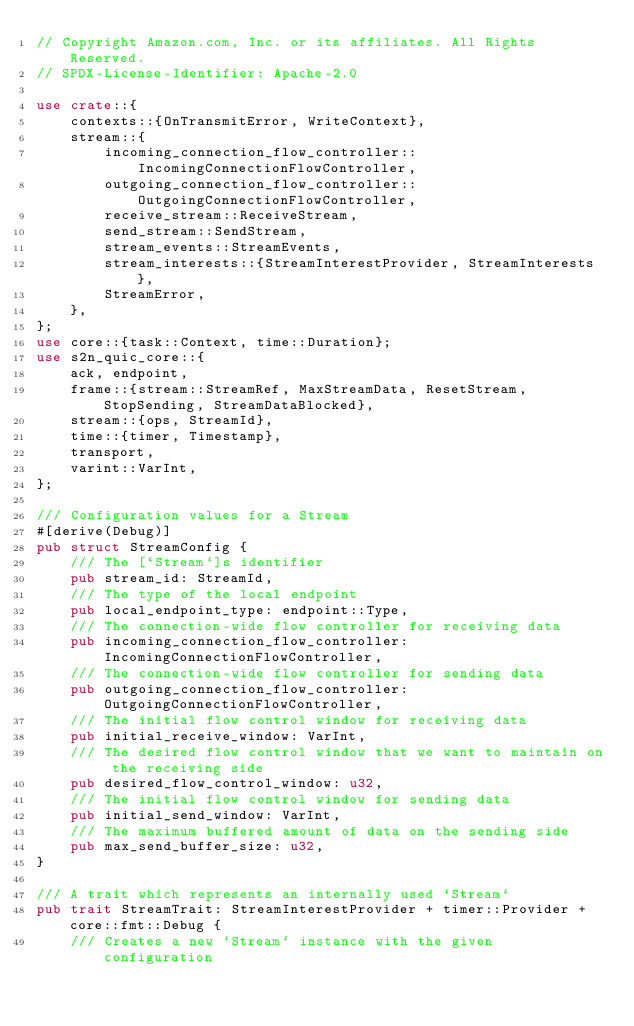<code> <loc_0><loc_0><loc_500><loc_500><_Rust_>// Copyright Amazon.com, Inc. or its affiliates. All Rights Reserved.
// SPDX-License-Identifier: Apache-2.0

use crate::{
    contexts::{OnTransmitError, WriteContext},
    stream::{
        incoming_connection_flow_controller::IncomingConnectionFlowController,
        outgoing_connection_flow_controller::OutgoingConnectionFlowController,
        receive_stream::ReceiveStream,
        send_stream::SendStream,
        stream_events::StreamEvents,
        stream_interests::{StreamInterestProvider, StreamInterests},
        StreamError,
    },
};
use core::{task::Context, time::Duration};
use s2n_quic_core::{
    ack, endpoint,
    frame::{stream::StreamRef, MaxStreamData, ResetStream, StopSending, StreamDataBlocked},
    stream::{ops, StreamId},
    time::{timer, Timestamp},
    transport,
    varint::VarInt,
};

/// Configuration values for a Stream
#[derive(Debug)]
pub struct StreamConfig {
    /// The [`Stream`]s identifier
    pub stream_id: StreamId,
    /// The type of the local endpoint
    pub local_endpoint_type: endpoint::Type,
    /// The connection-wide flow controller for receiving data
    pub incoming_connection_flow_controller: IncomingConnectionFlowController,
    /// The connection-wide flow controller for sending data
    pub outgoing_connection_flow_controller: OutgoingConnectionFlowController,
    /// The initial flow control window for receiving data
    pub initial_receive_window: VarInt,
    /// The desired flow control window that we want to maintain on the receiving side
    pub desired_flow_control_window: u32,
    /// The initial flow control window for sending data
    pub initial_send_window: VarInt,
    /// The maximum buffered amount of data on the sending side
    pub max_send_buffer_size: u32,
}

/// A trait which represents an internally used `Stream`
pub trait StreamTrait: StreamInterestProvider + timer::Provider + core::fmt::Debug {
    /// Creates a new `Stream` instance with the given configuration</code> 